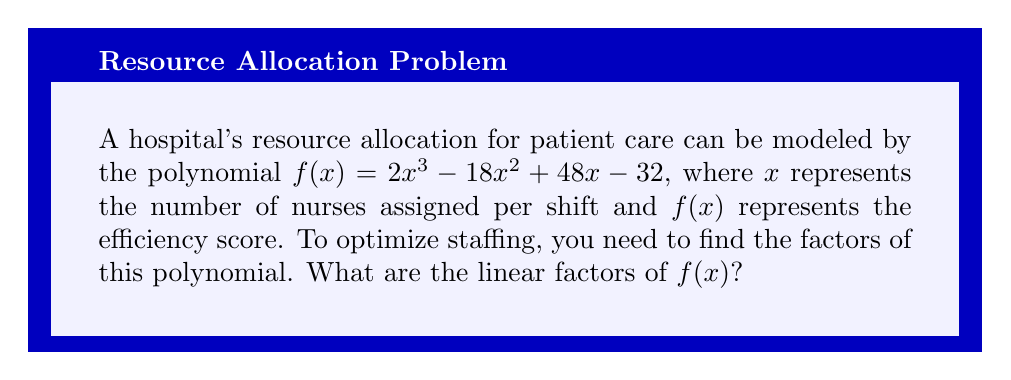What is the answer to this math problem? Let's approach this step-by-step:

1) First, we can factor out the greatest common factor (GCF):
   $f(x) = 2(x^3 - 9x^2 + 24x - 16)$

2) Now, let's try to guess one factor. Since the constant term is -16, possible factors are ±1, ±2, ±4, ±8, ±16. 
   Testing these, we find that $(x - 2)$ is a factor.

3) Divide the polynomial by $(x - 2)$:
   $x^3 - 9x^2 + 24x - 16 = (x - 2)(x^2 - 7x + 8)$

4) Now we need to factor the quadratic $x^2 - 7x + 8$:
   - The sum of its roots is 7
   - The product of its roots is 8
   - The factors of 8 that sum to 7 are 1 and 6

5) Therefore, $x^2 - 7x + 8 = (x - 1)(x - 6)$

6) Putting it all together:
   $f(x) = 2(x - 2)(x - 1)(x - 6)$

Thus, the linear factors are $(x - 2)$, $(x - 1)$, and $(x - 6)$.
Answer: $(x - 2)$, $(x - 1)$, $(x - 6)$ 